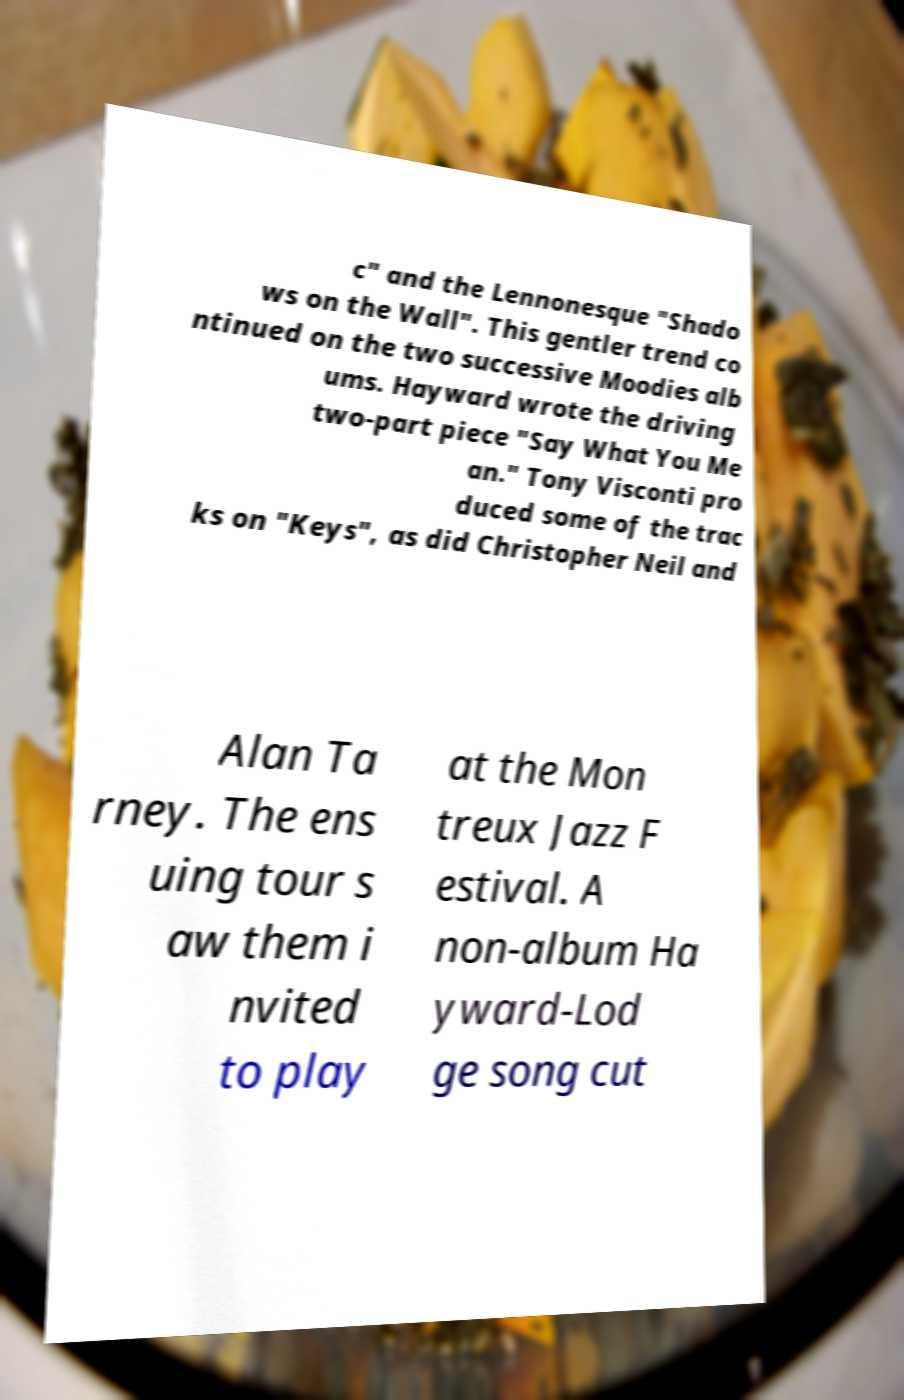For documentation purposes, I need the text within this image transcribed. Could you provide that? c" and the Lennonesque "Shado ws on the Wall". This gentler trend co ntinued on the two successive Moodies alb ums. Hayward wrote the driving two-part piece "Say What You Me an." Tony Visconti pro duced some of the trac ks on "Keys", as did Christopher Neil and Alan Ta rney. The ens uing tour s aw them i nvited to play at the Mon treux Jazz F estival. A non-album Ha yward-Lod ge song cut 